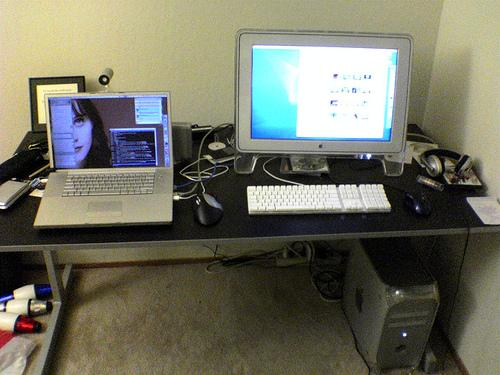How many computer displays are on top of the black desk with two mouses? Please explain your reasoning. two. There are two computer displays. one is a laptop and one is a desktop. 